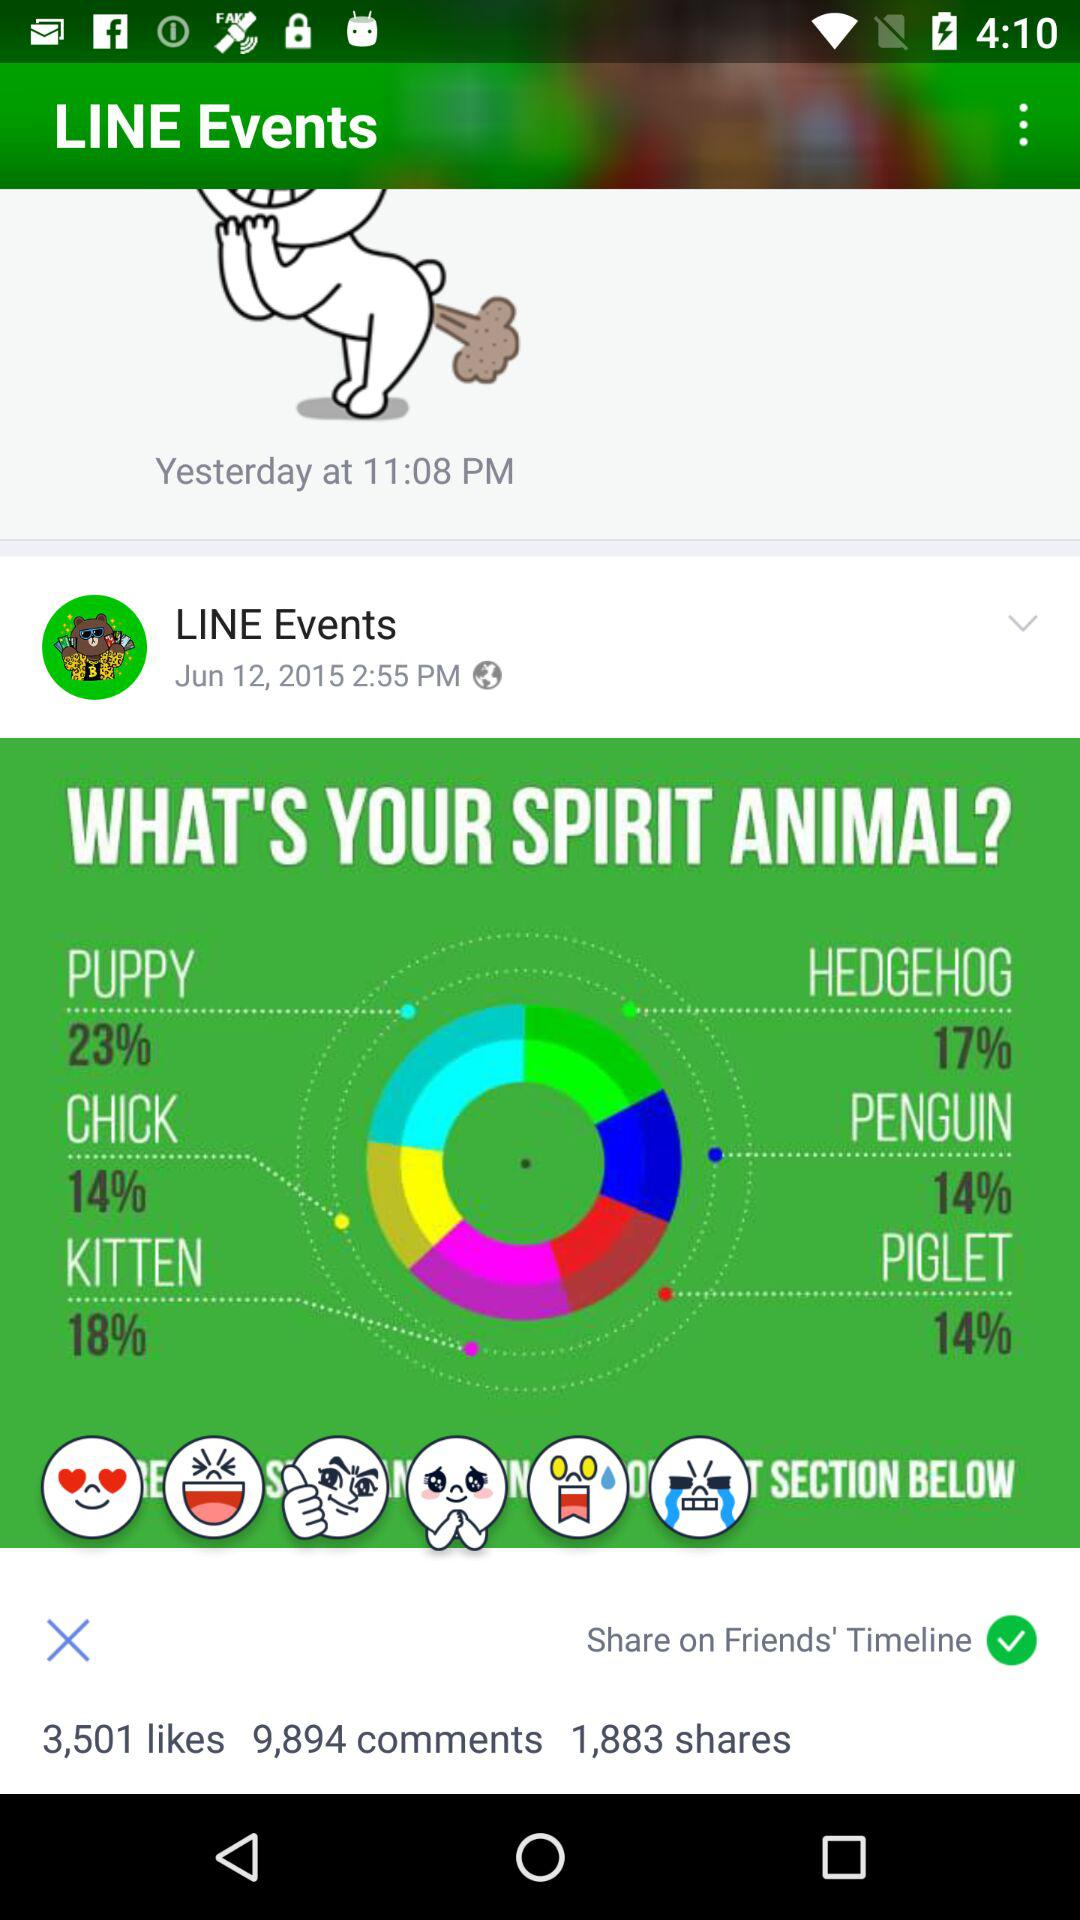What is the posted time of "LINE Events"? The posted time is 2:55 PM. 